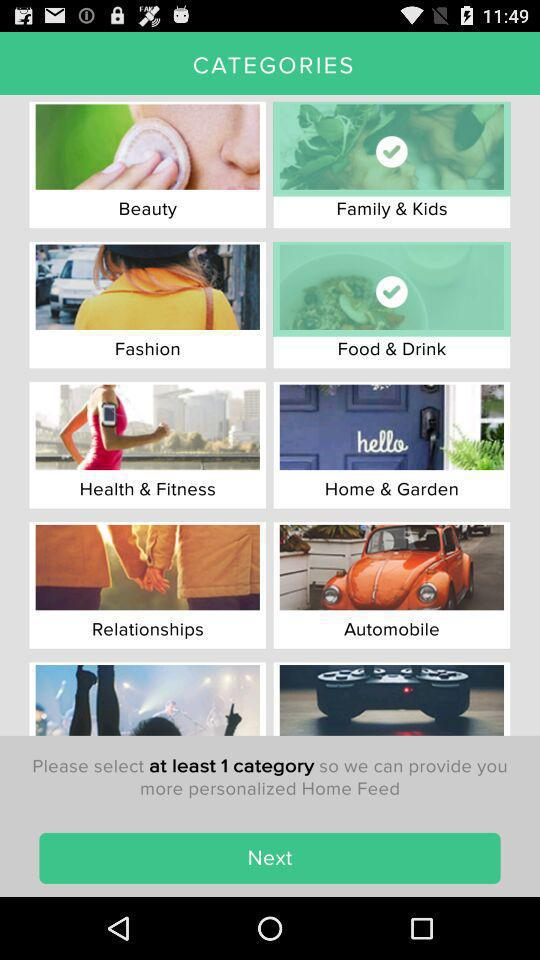What is the name of the application?
When the provided information is insufficient, respond with <no answer>. <no answer> 